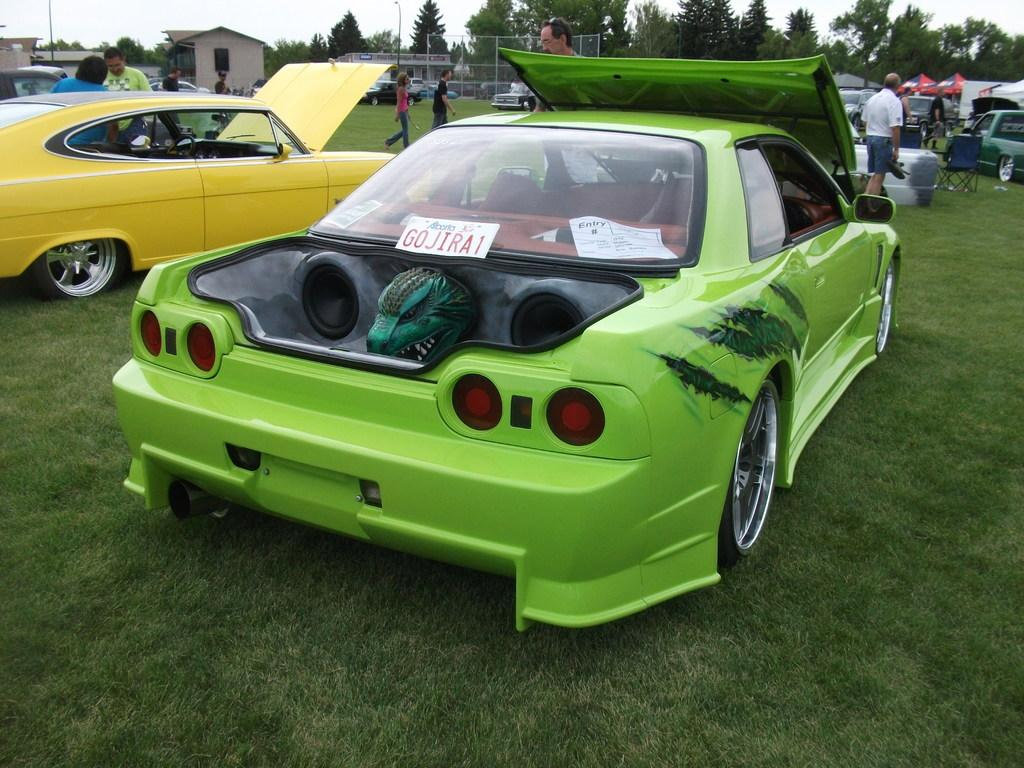<image>
Summarize the visual content of the image. Lime green vehicle at a car show with a license plate that says G0JIRA1. 